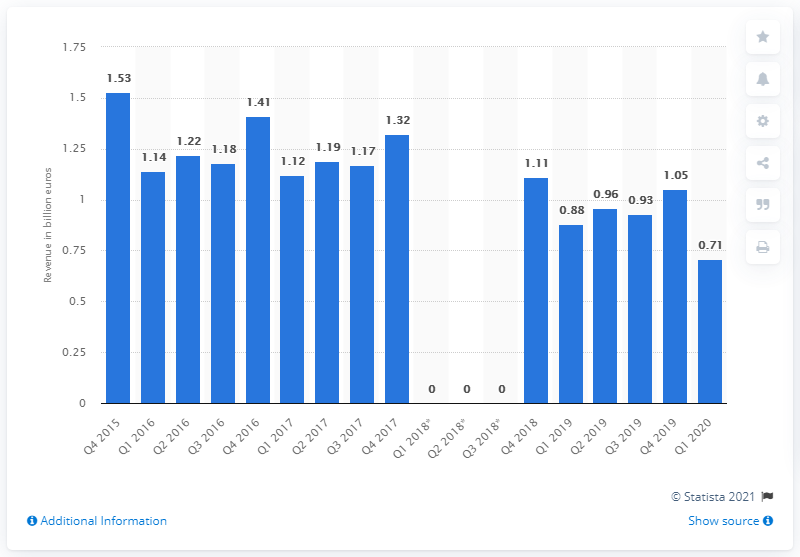Draw attention to some important aspects in this diagram. The decrease in photography equipment revenues from Q1 2019 to Q1 2020 was 0.71. 